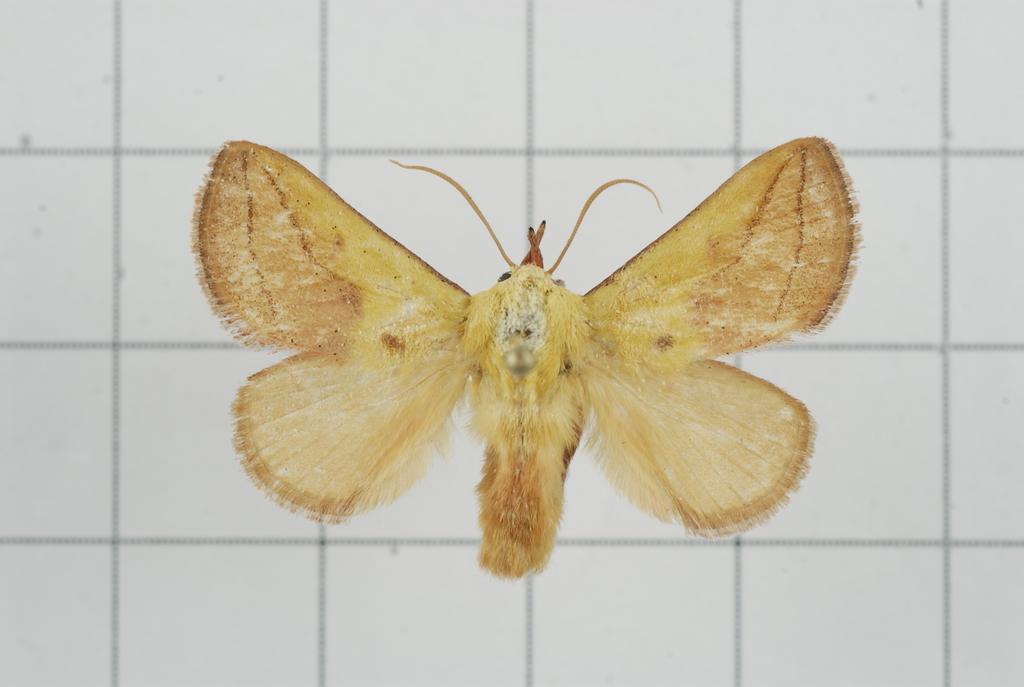How would you summarize this image in a sentence or two? In this image there is a butterfly , and there is white color background. 